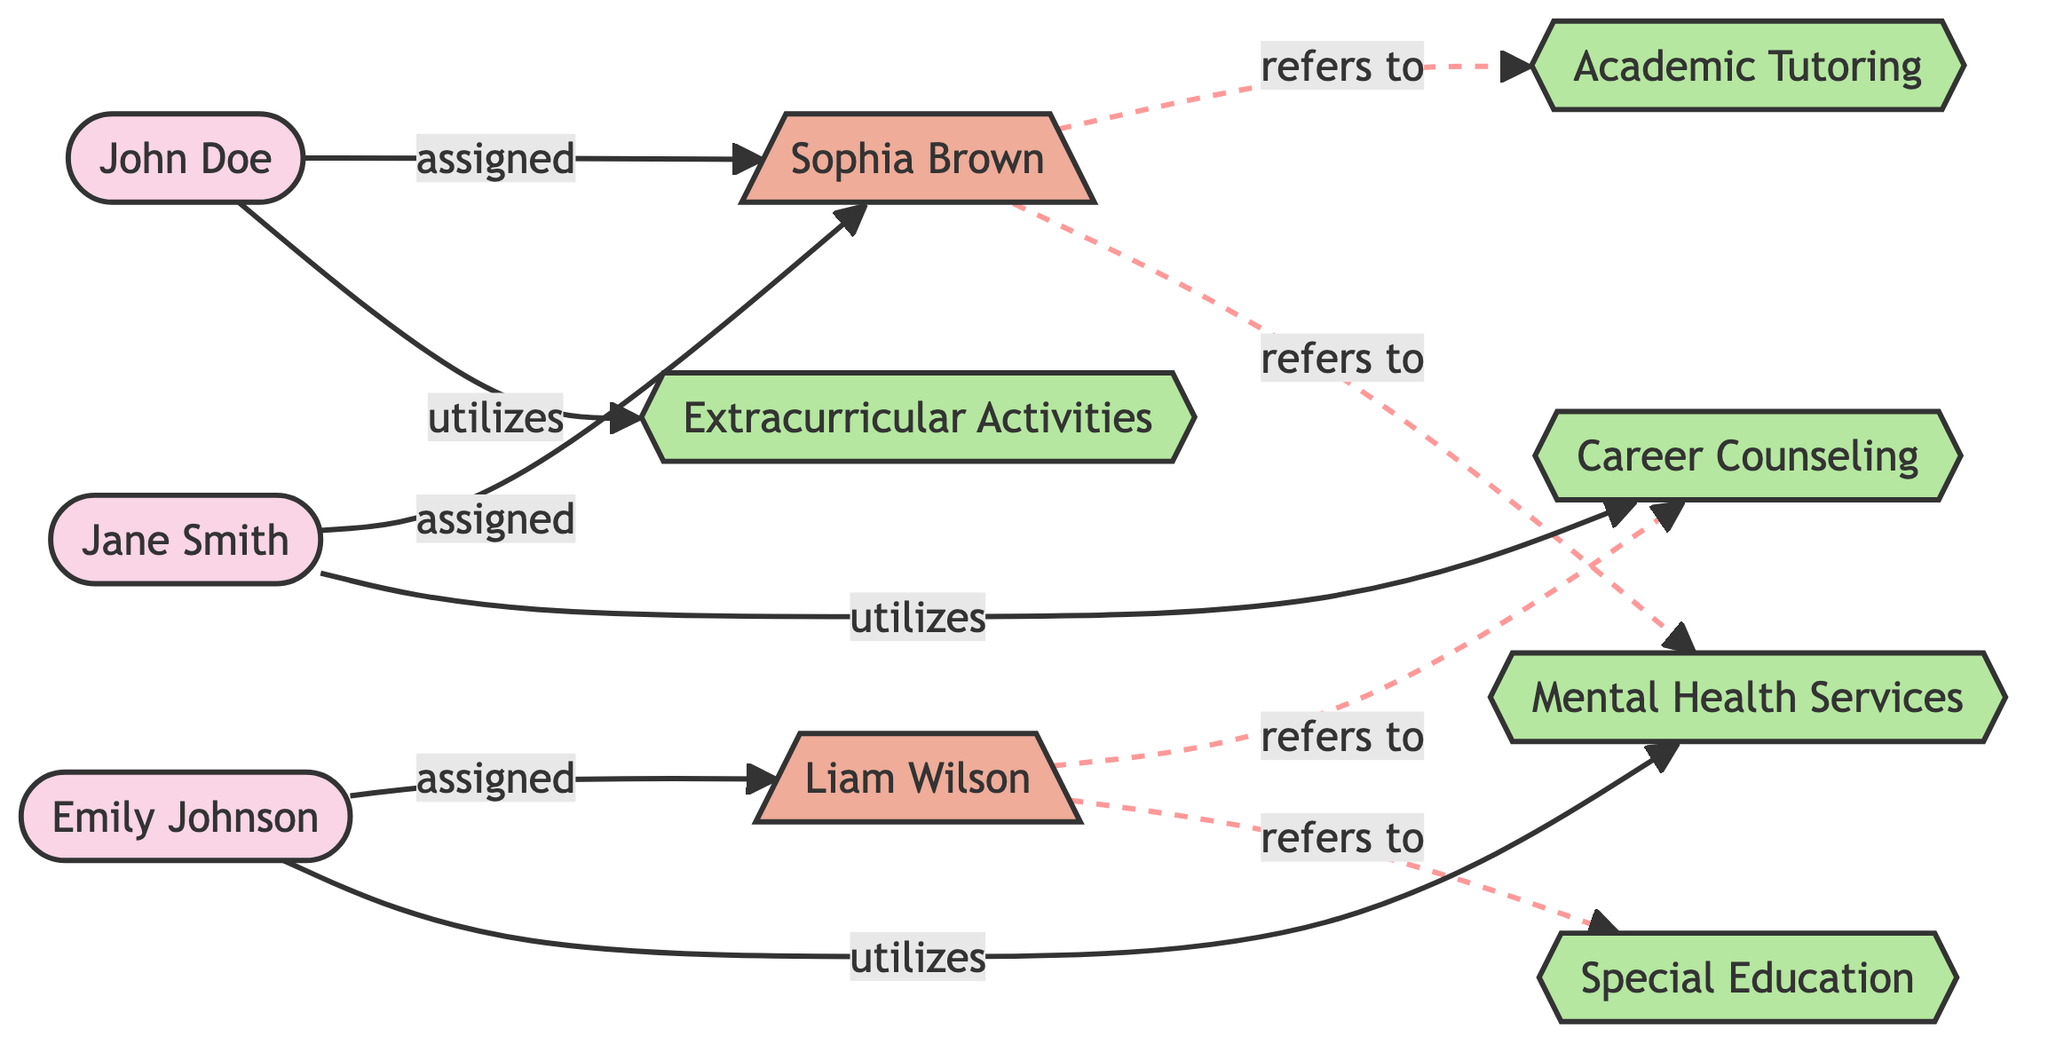What is the total number of students represented in the diagram? The diagram contains three students: John Doe, Jane Smith, and Emily Johnson.
Answer: 3 Which counselor is assigned to Jane Smith? The diagram shows that Jane Smith is assigned to counselor Sophia Brown.
Answer: Sophia Brown How many support services are provided in total? There are five support services listed in the diagram: Academic Tutoring, Mental Health Services, Career Counseling, Special Education, and Extracurricular Activities.
Answer: 5 What is the relationship between John Doe and Sophia Brown? John Doe is connected to Sophia Brown with the relationship "assigned counselor," indicating that she is his assigned counselor.
Answer: assigned counselor Which support service does Emily Johnson utilize? The diagram indicates that Emily Johnson utilizes Mental Health Services.
Answer: Mental Health Services Which support service is referred to by counselor Liam Wilson? Counselor Liam Wilson refers to Career Counseling and Special Education, according to the connections shown in the diagram.
Answer: Career Counseling and Special Education What is the relationship type between students and support services in the diagram? The relationship type shown between students and support services is "utilizes," indicating how students engage with various support services.
Answer: utilizes Who is the assigned counselor for student_1? Student John Doe, identified as student_1, is assigned to counselor Sophia Brown, as indicated in the diagram's connection.
Answer: Sophia Brown 